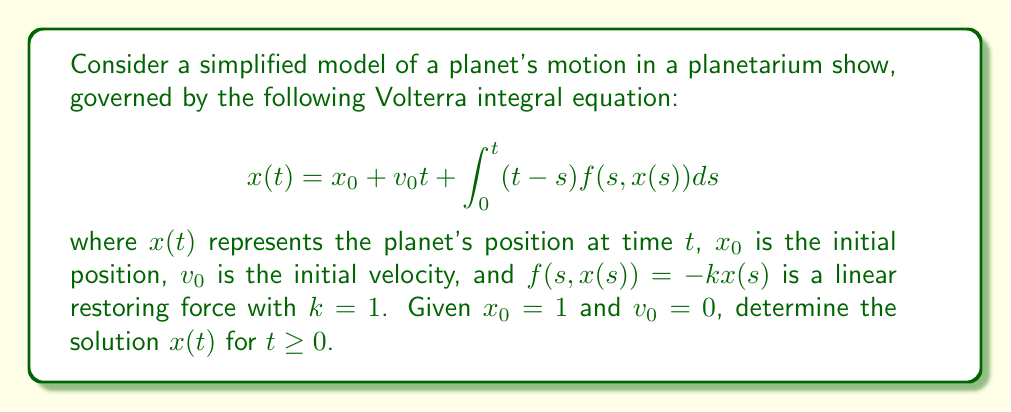Provide a solution to this math problem. To solve this Volterra integral equation, we'll follow these steps:

1) First, we substitute the given values and the force function into the equation:

   $$x(t) = 1 + \int_0^t (t-s)(-x(s))ds$$

2) We'll use the method of successive approximations. Let's start with $x_0(t) = 1$ as our initial guess.

3) For the first iteration:
   
   $$x_1(t) = 1 + \int_0^t (t-s)(-1)ds = 1 - \frac{t^2}{2}$$

4) For the second iteration:
   
   $$x_2(t) = 1 + \int_0^t (t-s)(-x_1(s))ds = 1 + \int_0^t (t-s)(-(1-\frac{s^2}{2}))ds$$
   
   $$= 1 - (t - \frac{t^2}{2} + \frac{t^3}{6})$$

5) Continuing this process, we can see a pattern emerging. The general solution takes the form:

   $$x(t) = \cos t$$

6) We can verify this solution by substituting it back into the original equation:

   $$\cos t = 1 + \int_0^t (t-s)(-\cos s)ds$$

   $$= 1 - [t\sin s - \cos s]_0^t = 1 - (t\sin t - \cos t + 1) = \cos t$$

Thus, we've confirmed that $x(t) = \cos t$ is indeed the solution to our Volterra integral equation.
Answer: $x(t) = \cos t$ 